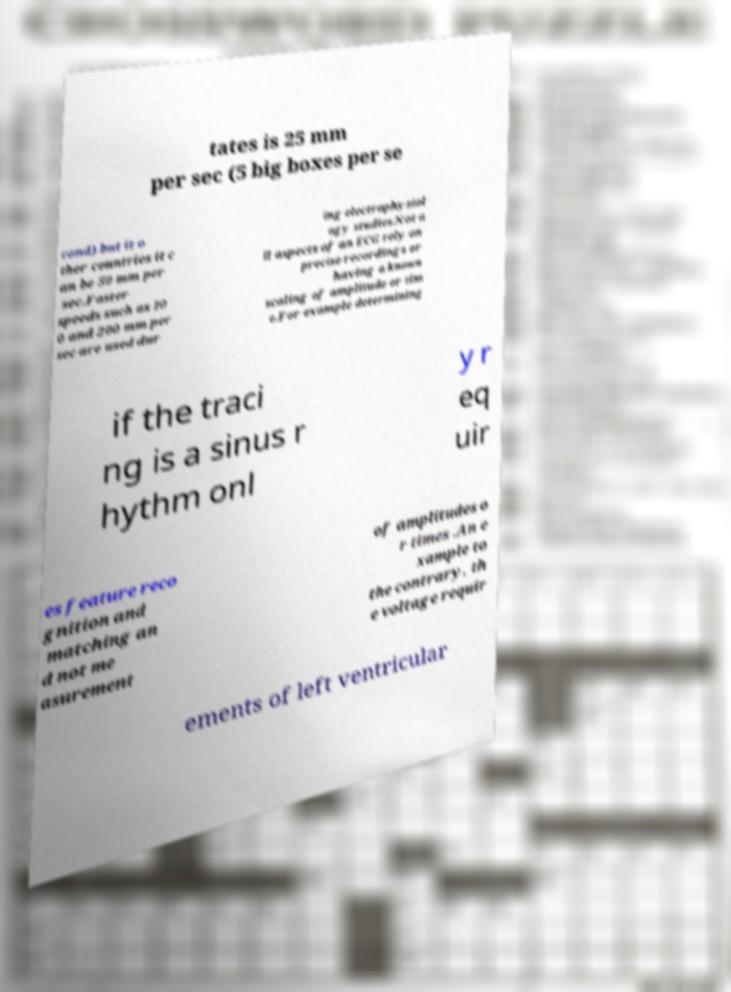For documentation purposes, I need the text within this image transcribed. Could you provide that? tates is 25 mm per sec (5 big boxes per se cond) but it o ther countries it c an be 50 mm per sec.Faster speeds such as 10 0 and 200 mm per sec are used dur ing electrophysiol ogy studies.Not a ll aspects of an ECG rely on precise recordings or having a known scaling of amplitude or tim e.For example determining if the traci ng is a sinus r hythm onl y r eq uir es feature reco gnition and matching an d not me asurement of amplitudes o r times .An e xample to the contrary, th e voltage requir ements of left ventricular 